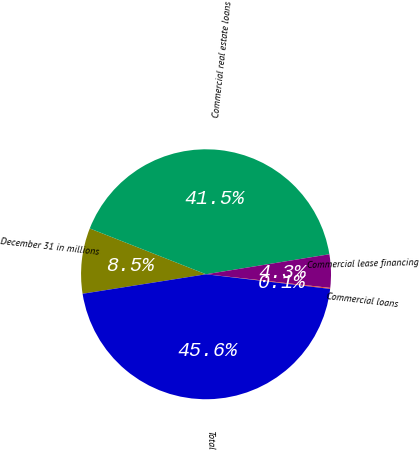Convert chart. <chart><loc_0><loc_0><loc_500><loc_500><pie_chart><fcel>December 31 in millions<fcel>Commercial real estate loans<fcel>Commercial lease financing<fcel>Commercial loans<fcel>Total<nl><fcel>8.47%<fcel>41.47%<fcel>4.3%<fcel>0.13%<fcel>45.64%<nl></chart> 